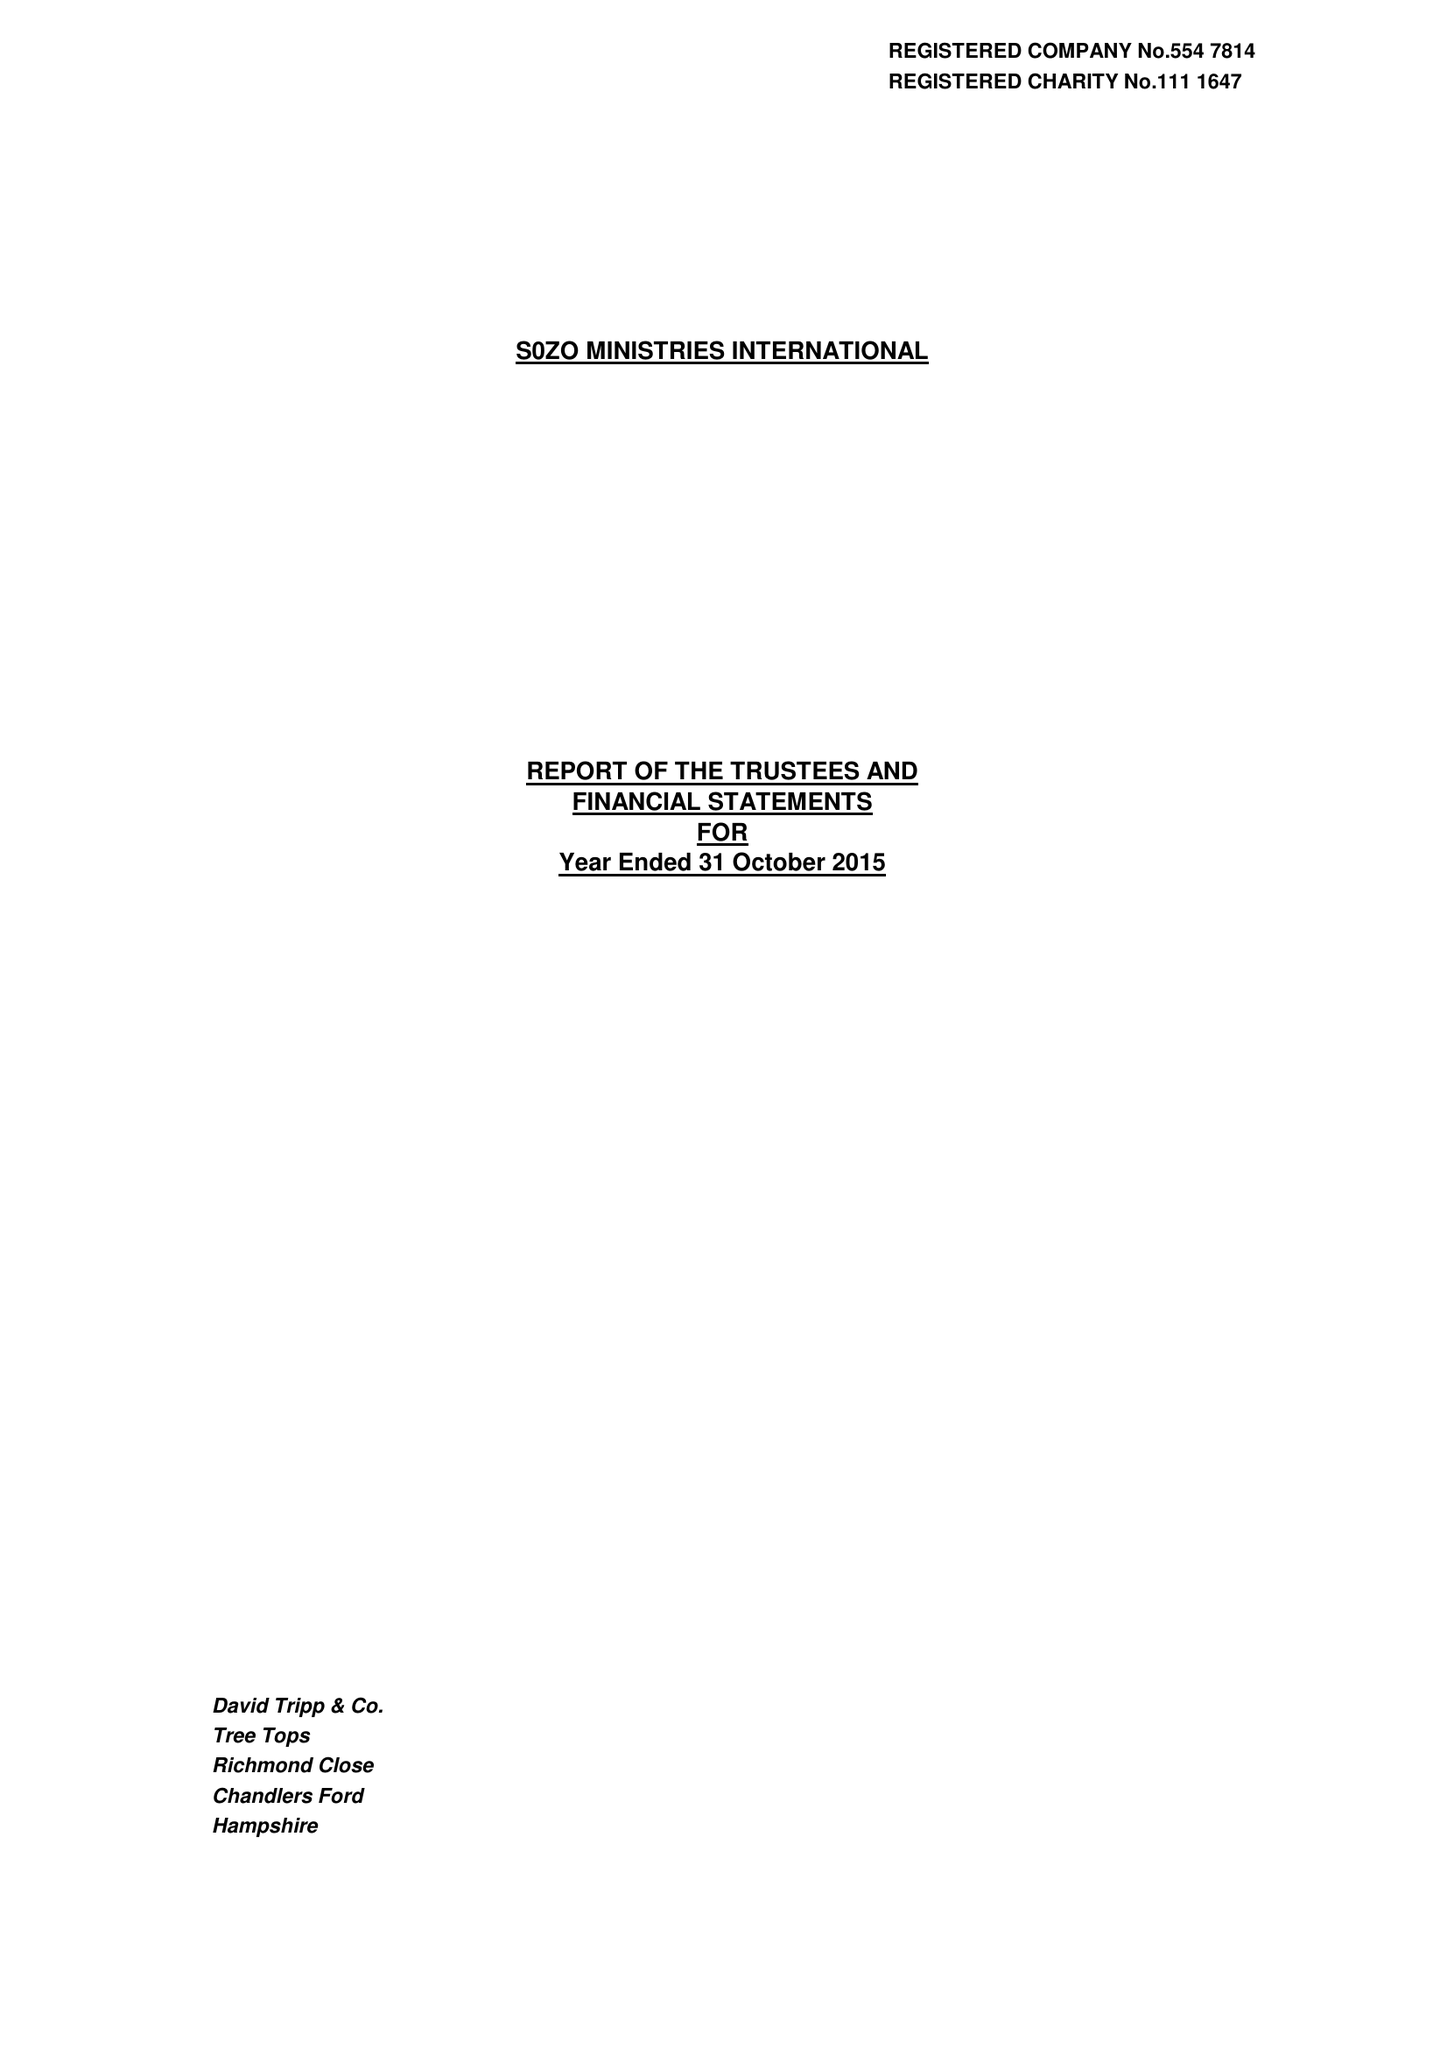What is the value for the address__postcode?
Answer the question using a single word or phrase. SO51 0GF 